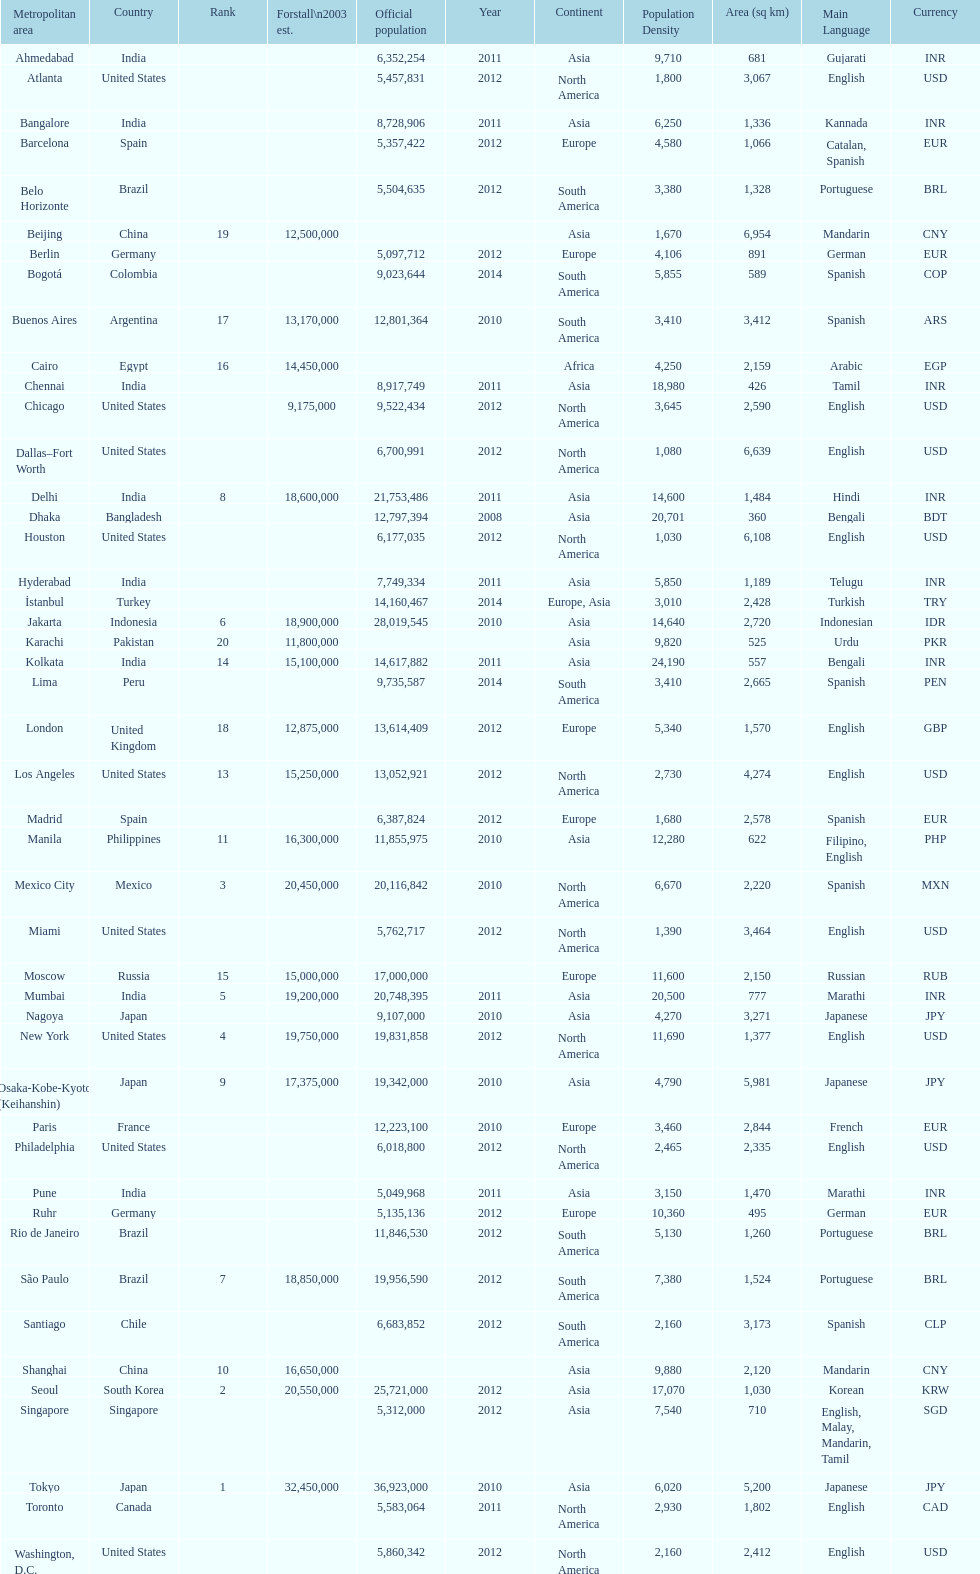Which areas had a population of more than 10,000,000 but less than 20,000,000? Buenos Aires, Dhaka, İstanbul, Kolkata, London, Los Angeles, Manila, Moscow, New York, Osaka-Kobe-Kyoto (Keihanshin), Paris, Rio de Janeiro, São Paulo. 